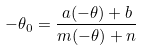Convert formula to latex. <formula><loc_0><loc_0><loc_500><loc_500>- \theta _ { 0 } = \frac { a ( - \theta ) + b } { m ( - \theta ) + n }</formula> 